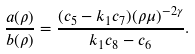Convert formula to latex. <formula><loc_0><loc_0><loc_500><loc_500>\frac { a ( \rho ) } { b ( \rho ) } = \frac { ( c _ { 5 } - k _ { 1 } c _ { 7 } ) ( \rho \mu ) ^ { - 2 \gamma } } { k _ { 1 } c _ { 8 } - c _ { 6 } } .</formula> 